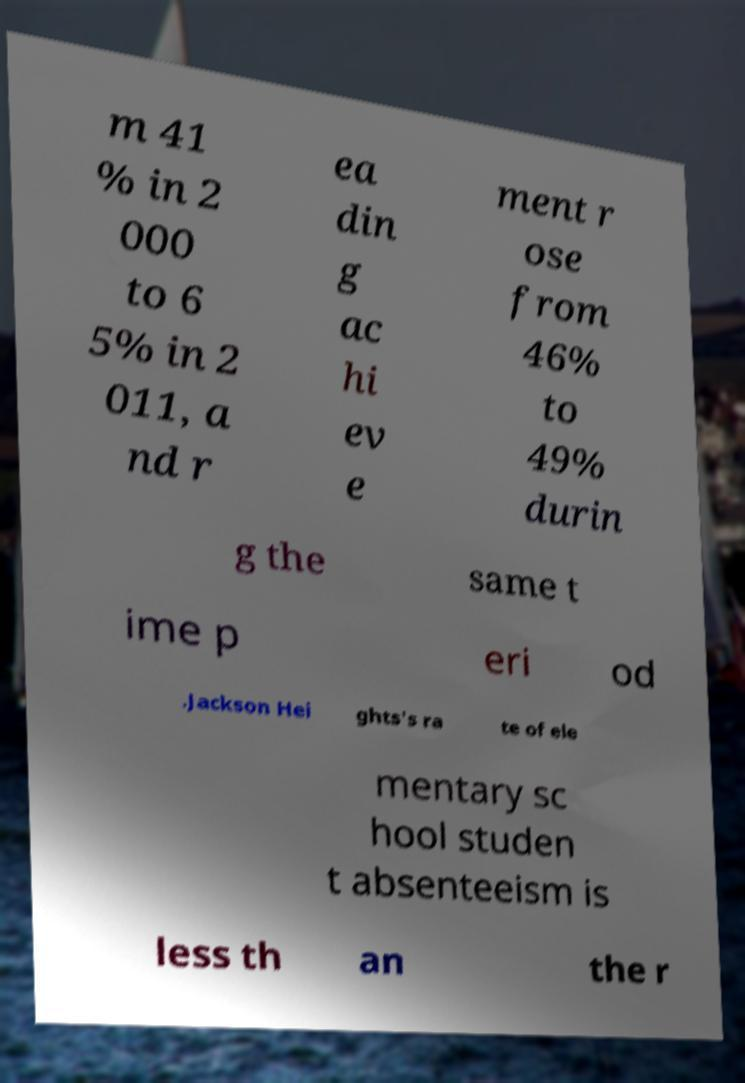Please read and relay the text visible in this image. What does it say? m 41 % in 2 000 to 6 5% in 2 011, a nd r ea din g ac hi ev e ment r ose from 46% to 49% durin g the same t ime p eri od .Jackson Hei ghts's ra te of ele mentary sc hool studen t absenteeism is less th an the r 